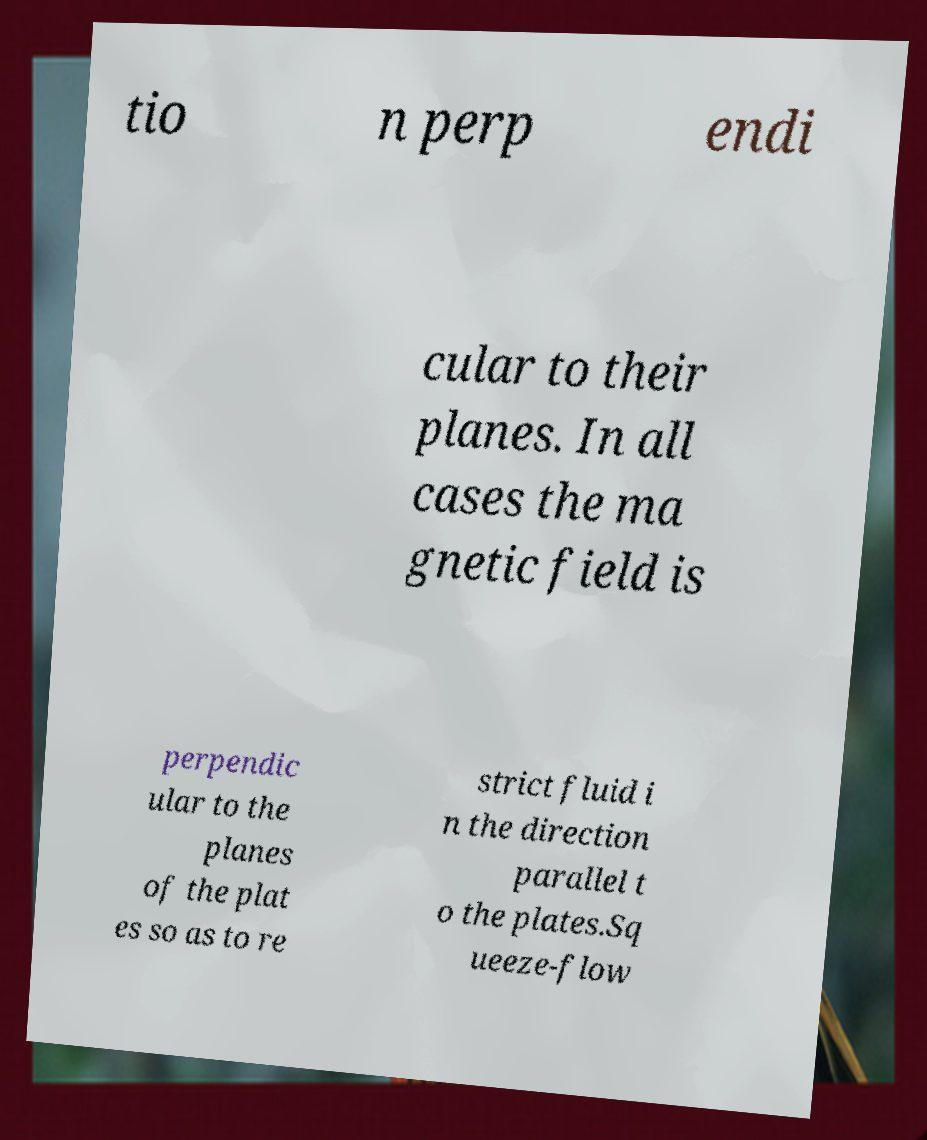Please identify and transcribe the text found in this image. tio n perp endi cular to their planes. In all cases the ma gnetic field is perpendic ular to the planes of the plat es so as to re strict fluid i n the direction parallel t o the plates.Sq ueeze-flow 